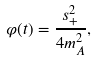Convert formula to latex. <formula><loc_0><loc_0><loc_500><loc_500>\varphi ( t ) = \frac { s _ { + } ^ { 2 } } { 4 m _ { A } ^ { 2 } } ,</formula> 